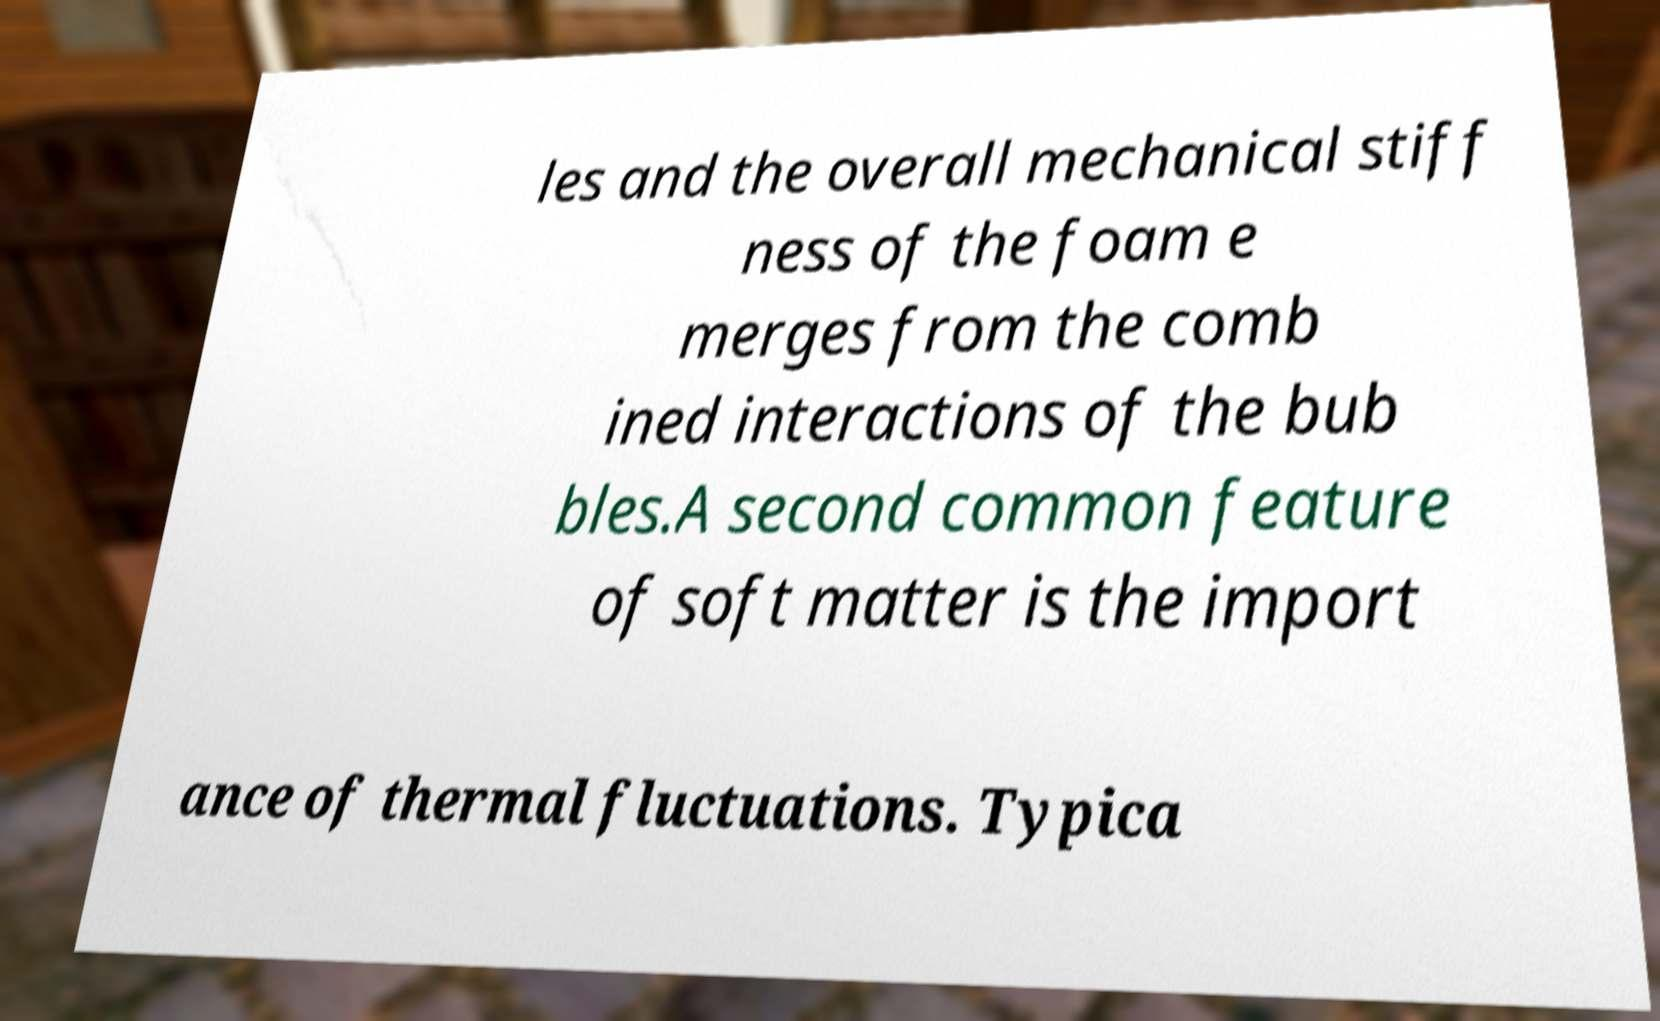There's text embedded in this image that I need extracted. Can you transcribe it verbatim? les and the overall mechanical stiff ness of the foam e merges from the comb ined interactions of the bub bles.A second common feature of soft matter is the import ance of thermal fluctuations. Typica 